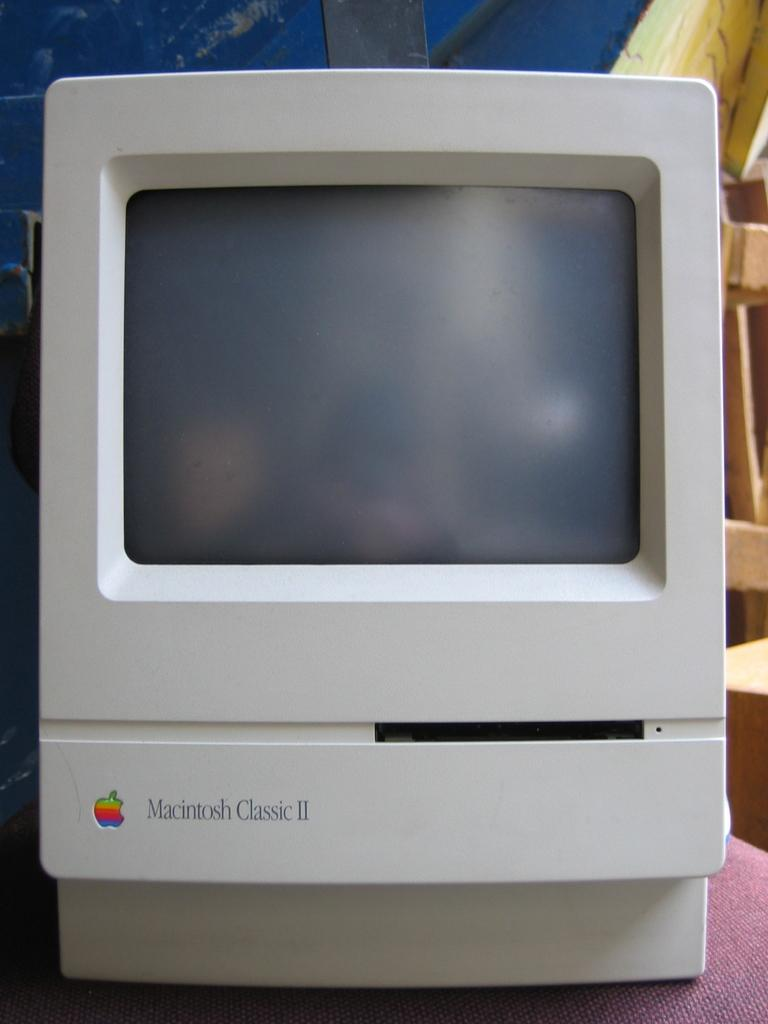<image>
Present a compact description of the photo's key features. A macintosh branded computer monitor with a slot for a floppy disc. 